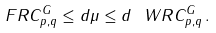<formula> <loc_0><loc_0><loc_500><loc_500>\ F R C _ { p , q } ^ { G } \leq d \mu \leq d \ W R C _ { p , q } ^ { G } \, .</formula> 